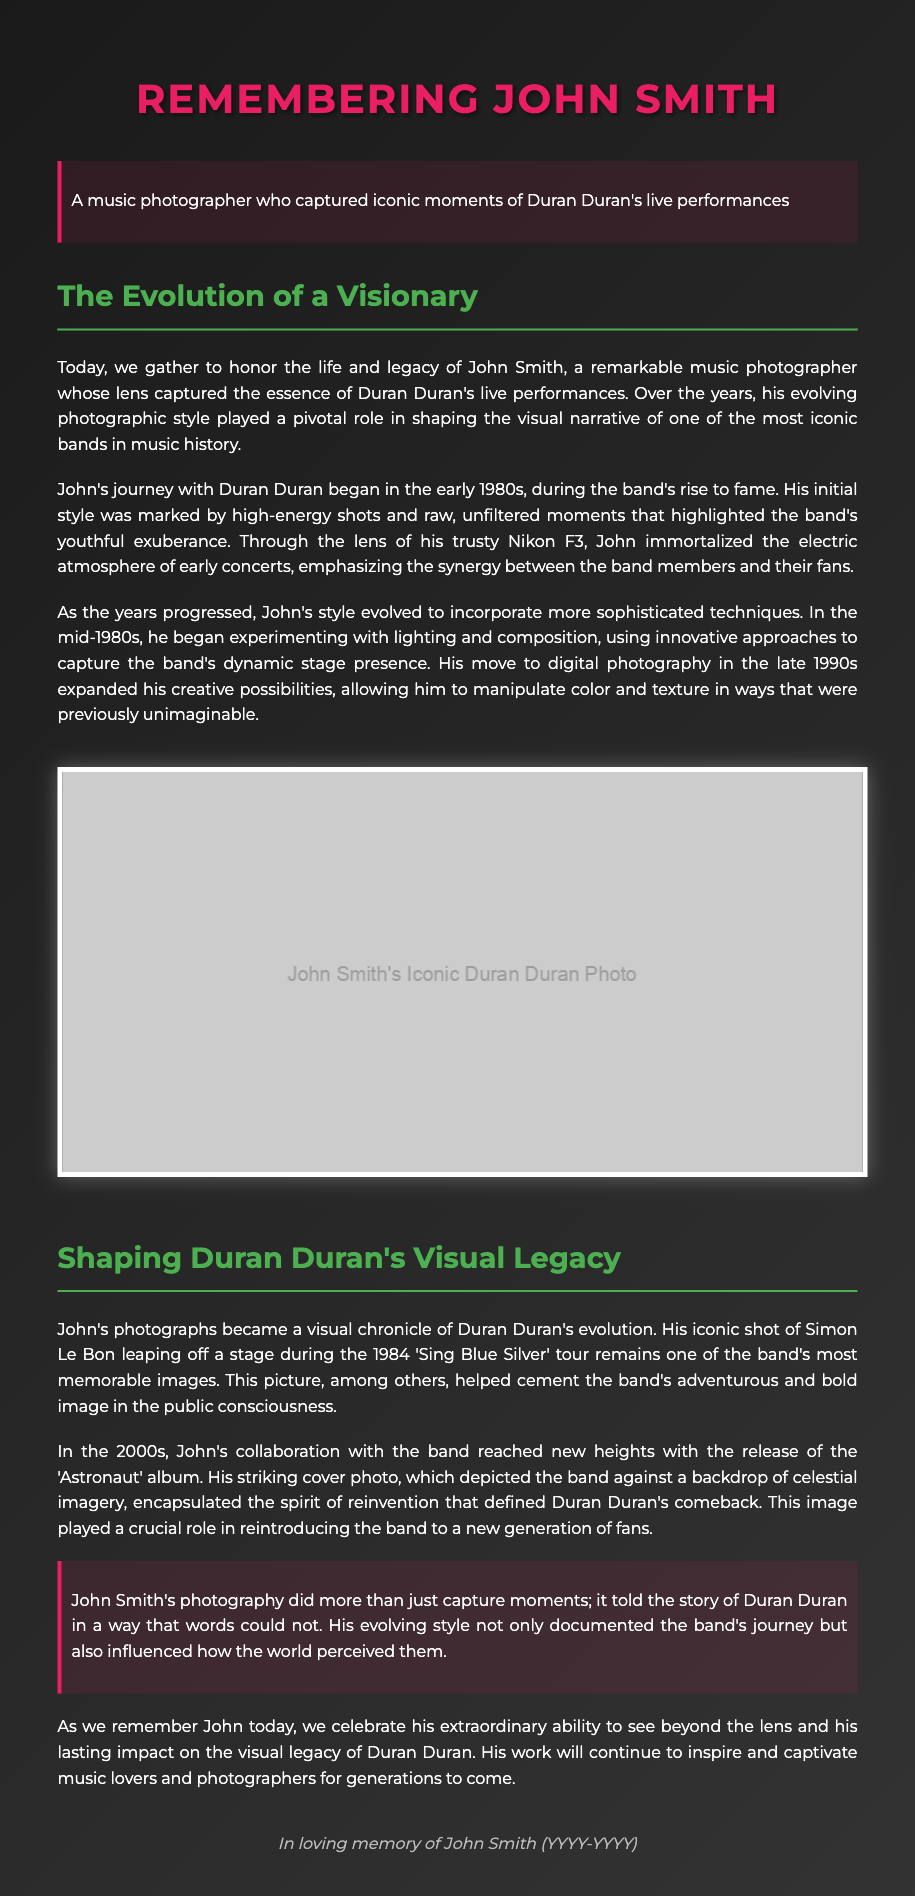What decade did John begin photographing Duran Duran? The document mentions that John started his journey with Duran Duran in the early 1980s.
Answer: early 1980s What brand of camera did John use in the beginning? John used a Nikon F3 for his early photographs of Duran Duran.
Answer: Nikon F3 Which Duran Duran album did John photograph for in the 2000s? The document specifically mentions John's collaboration with the band for the release of the 'Astronaut' album.
Answer: Astronaut What was the iconic photo of Simon Le Bon taken during? The photo of Simon Le Bon was taken during the 1984 'Sing Blue Silver' tour.
Answer: 1984 'Sing Blue Silver' tour How did John's photographic style change in the mid-1980s? In the mid-1980s, John began experimenting with lighting and composition, indicating a more sophisticated approach to his photography.
Answer: more sophisticated techniques 